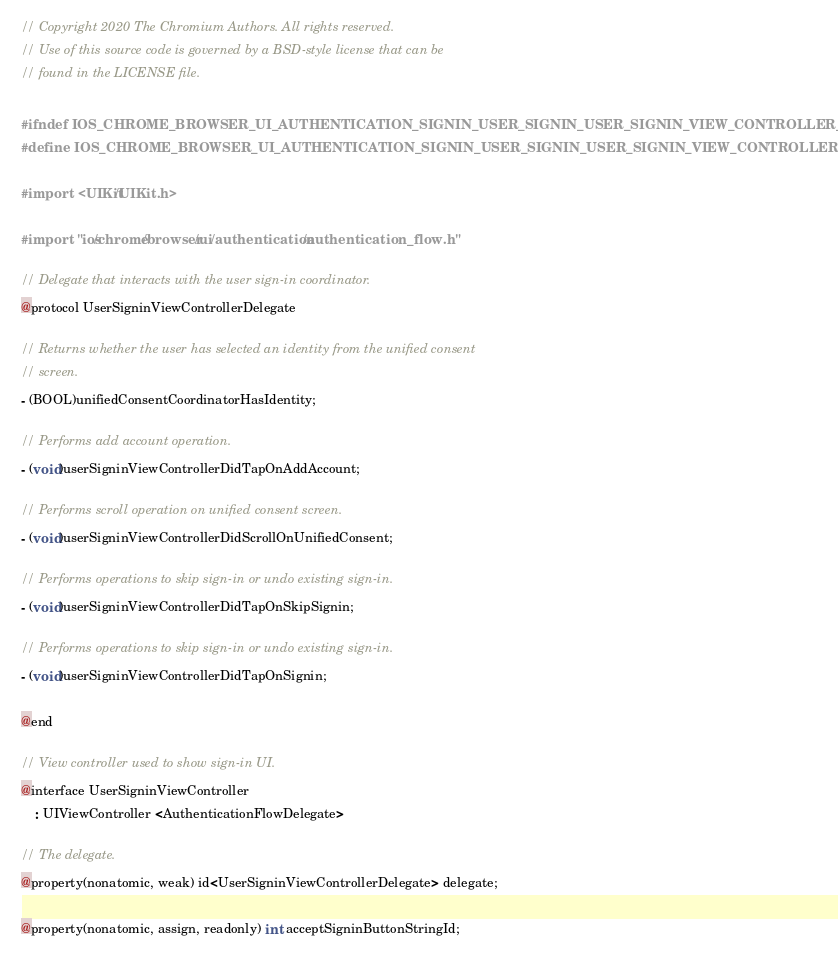<code> <loc_0><loc_0><loc_500><loc_500><_C_>// Copyright 2020 The Chromium Authors. All rights reserved.
// Use of this source code is governed by a BSD-style license that can be
// found in the LICENSE file.

#ifndef IOS_CHROME_BROWSER_UI_AUTHENTICATION_SIGNIN_USER_SIGNIN_USER_SIGNIN_VIEW_CONTROLLER_H_
#define IOS_CHROME_BROWSER_UI_AUTHENTICATION_SIGNIN_USER_SIGNIN_USER_SIGNIN_VIEW_CONTROLLER_H_

#import <UIKit/UIKit.h>

#import "ios/chrome/browser/ui/authentication/authentication_flow.h"

// Delegate that interacts with the user sign-in coordinator.
@protocol UserSigninViewControllerDelegate

// Returns whether the user has selected an identity from the unified consent
// screen.
- (BOOL)unifiedConsentCoordinatorHasIdentity;

// Performs add account operation.
- (void)userSigninViewControllerDidTapOnAddAccount;

// Performs scroll operation on unified consent screen.
- (void)userSigninViewControllerDidScrollOnUnifiedConsent;

// Performs operations to skip sign-in or undo existing sign-in.
- (void)userSigninViewControllerDidTapOnSkipSignin;

// Performs operations to skip sign-in or undo existing sign-in.
- (void)userSigninViewControllerDidTapOnSignin;

@end

// View controller used to show sign-in UI.
@interface UserSigninViewController
    : UIViewController <AuthenticationFlowDelegate>

// The delegate.
@property(nonatomic, weak) id<UserSigninViewControllerDelegate> delegate;

@property(nonatomic, assign, readonly) int acceptSigninButtonStringId;
</code> 